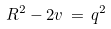<formula> <loc_0><loc_0><loc_500><loc_500>R ^ { 2 } - 2 v \, = \, q ^ { 2 }</formula> 